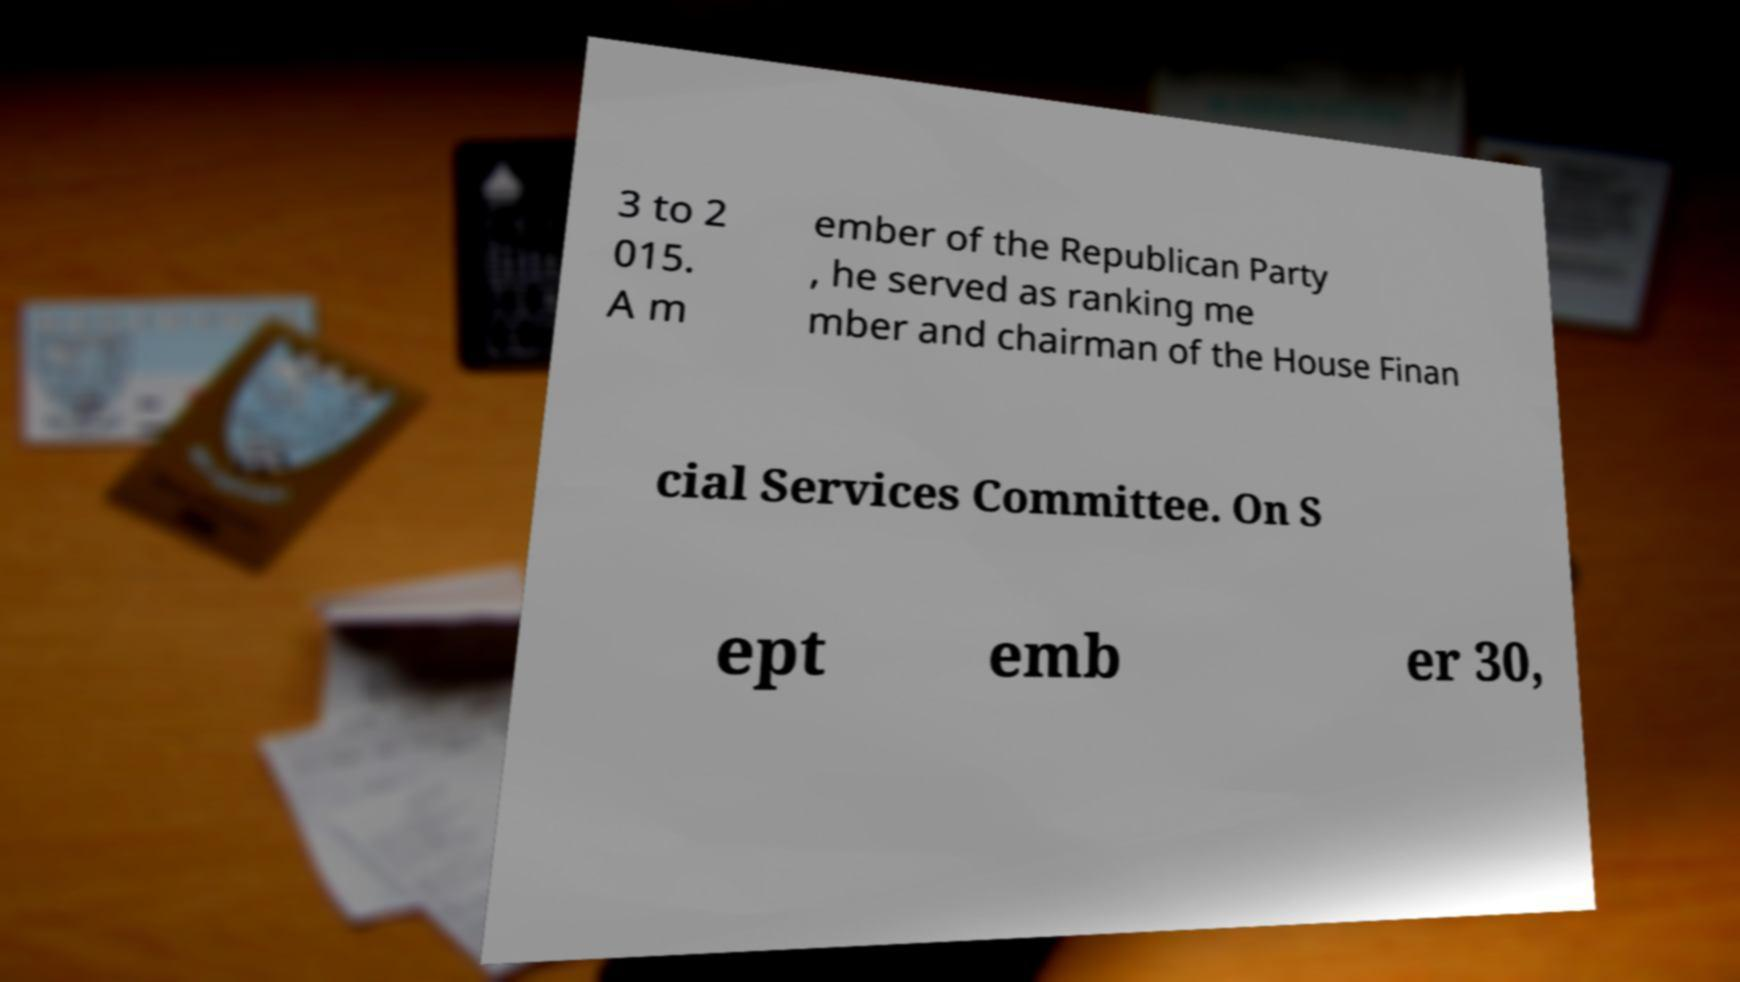There's text embedded in this image that I need extracted. Can you transcribe it verbatim? 3 to 2 015. A m ember of the Republican Party , he served as ranking me mber and chairman of the House Finan cial Services Committee. On S ept emb er 30, 